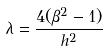Convert formula to latex. <formula><loc_0><loc_0><loc_500><loc_500>\lambda = \frac { 4 ( \beta ^ { 2 } - 1 ) } { h ^ { 2 } }</formula> 